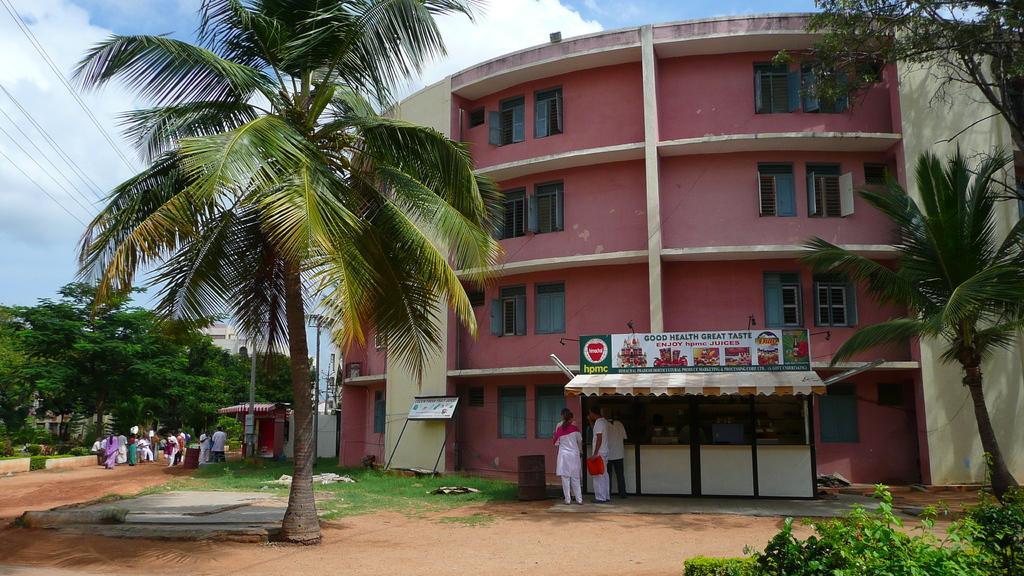Please provide a concise description of this image. In the center of the image there is a building, persons and store. On the right side of the image we can see plants and trees. On the left side of the image we can see trees, persons, pole. In the background we can see sky and clouds. 